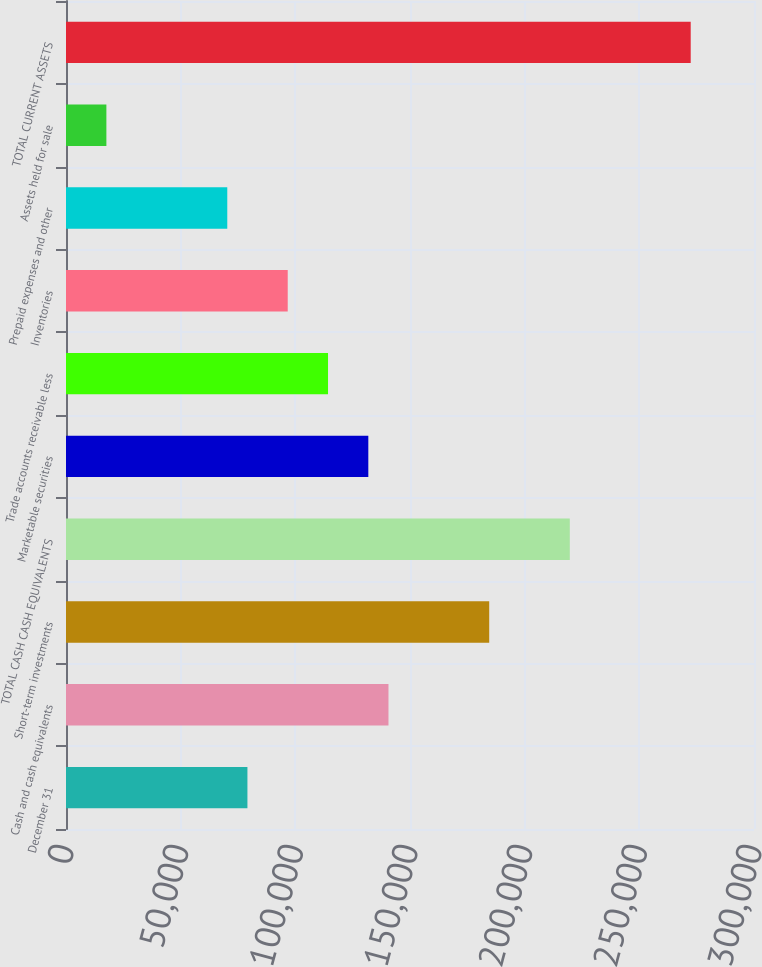Convert chart to OTSL. <chart><loc_0><loc_0><loc_500><loc_500><bar_chart><fcel>December 31<fcel>Cash and cash equivalents<fcel>Short-term investments<fcel>TOTAL CASH CASH EQUIVALENTS<fcel>Marketable securities<fcel>Trade accounts receivable less<fcel>Inventories<fcel>Prepaid expenses and other<fcel>Assets held for sale<fcel>TOTAL CURRENT ASSETS<nl><fcel>79110.1<fcel>140611<fcel>184541<fcel>219684<fcel>131826<fcel>114254<fcel>96681.9<fcel>70324.2<fcel>17608.8<fcel>272400<nl></chart> 